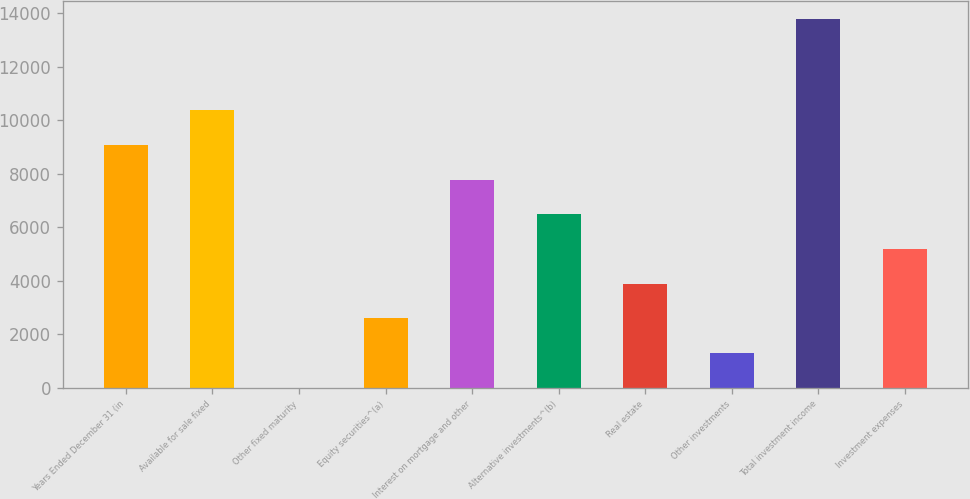<chart> <loc_0><loc_0><loc_500><loc_500><bar_chart><fcel>Years Ended December 31 (in<fcel>Available for sale fixed<fcel>Other fixed maturity<fcel>Equity securities^(a)<fcel>Interest on mortgage and other<fcel>Alternative investments^(b)<fcel>Real estate<fcel>Other investments<fcel>Total investment income<fcel>Investment expenses<nl><fcel>9080.4<fcel>10376.6<fcel>7<fcel>2599.4<fcel>7784.2<fcel>6488<fcel>3895.6<fcel>1303.2<fcel>13772.2<fcel>5191.8<nl></chart> 